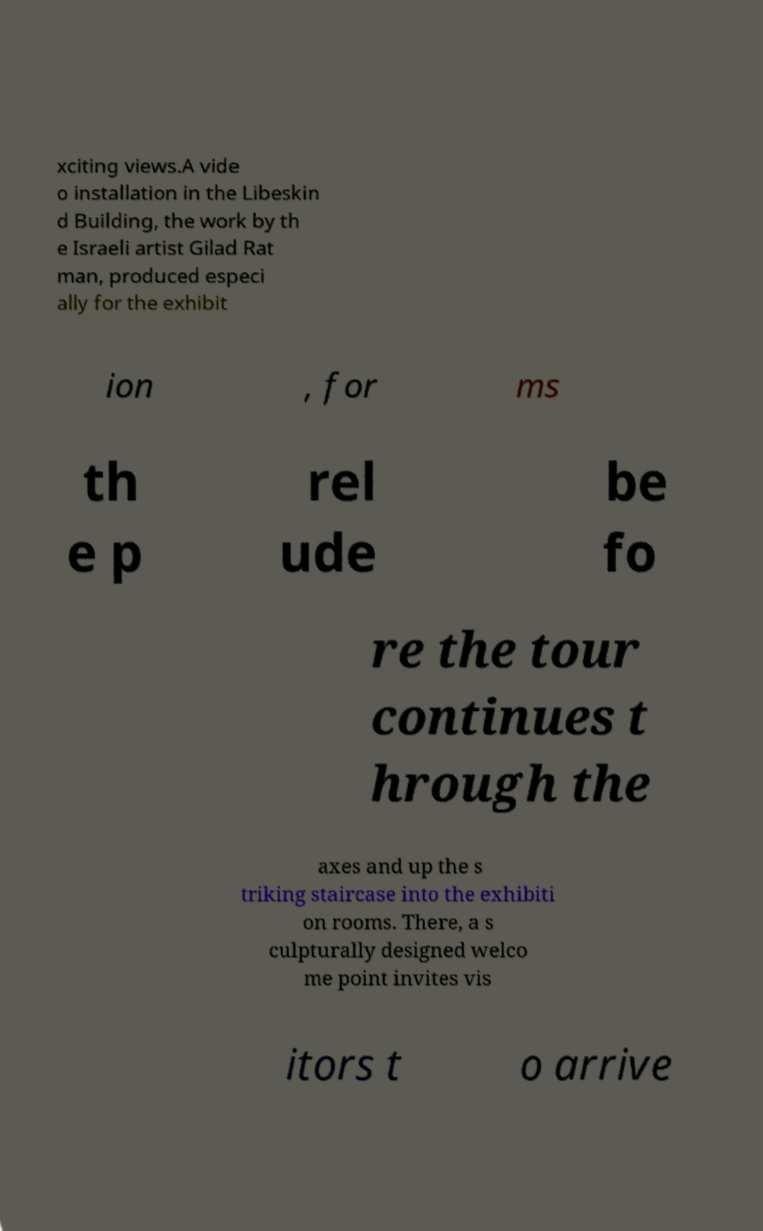What messages or text are displayed in this image? I need them in a readable, typed format. xciting views.A vide o installation in the Libeskin d Building, the work by th e Israeli artist Gilad Rat man, produced especi ally for the exhibit ion , for ms th e p rel ude be fo re the tour continues t hrough the axes and up the s triking staircase into the exhibiti on rooms. There, a s culpturally designed welco me point invites vis itors t o arrive 